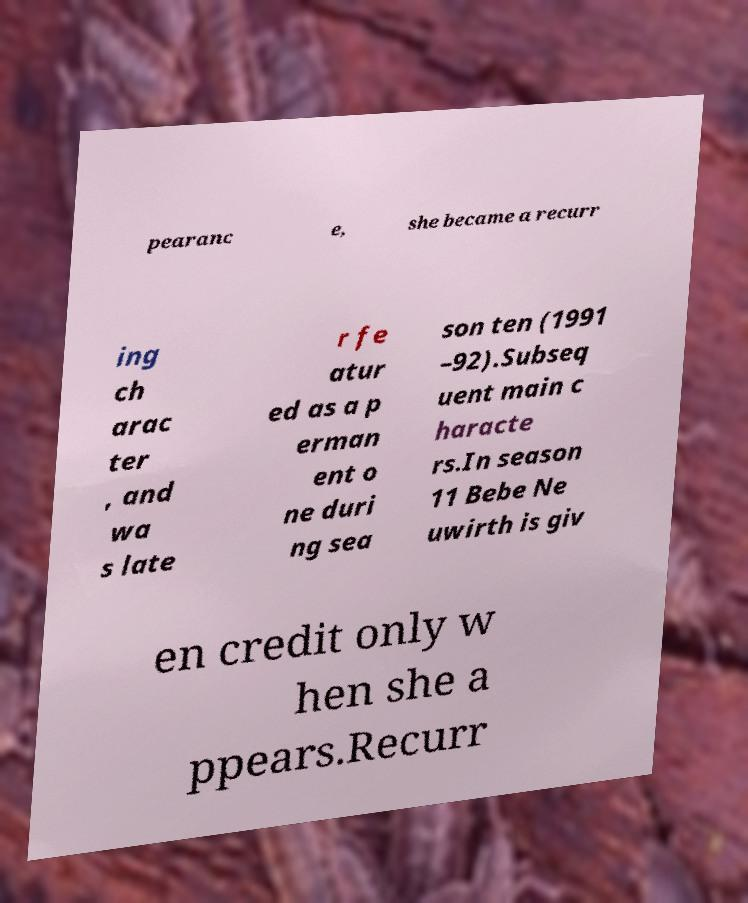Please read and relay the text visible in this image. What does it say? pearanc e, she became a recurr ing ch arac ter , and wa s late r fe atur ed as a p erman ent o ne duri ng sea son ten (1991 –92).Subseq uent main c haracte rs.In season 11 Bebe Ne uwirth is giv en credit only w hen she a ppears.Recurr 